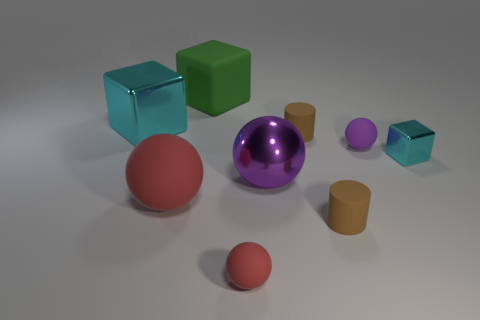Subtract 1 balls. How many balls are left? 3 Add 1 small blocks. How many objects exist? 10 Subtract all cylinders. How many objects are left? 7 Add 2 large cyan things. How many large cyan things are left? 3 Add 9 big cyan things. How many big cyan things exist? 10 Subtract 2 brown cylinders. How many objects are left? 7 Subtract all large purple metallic spheres. Subtract all red rubber things. How many objects are left? 6 